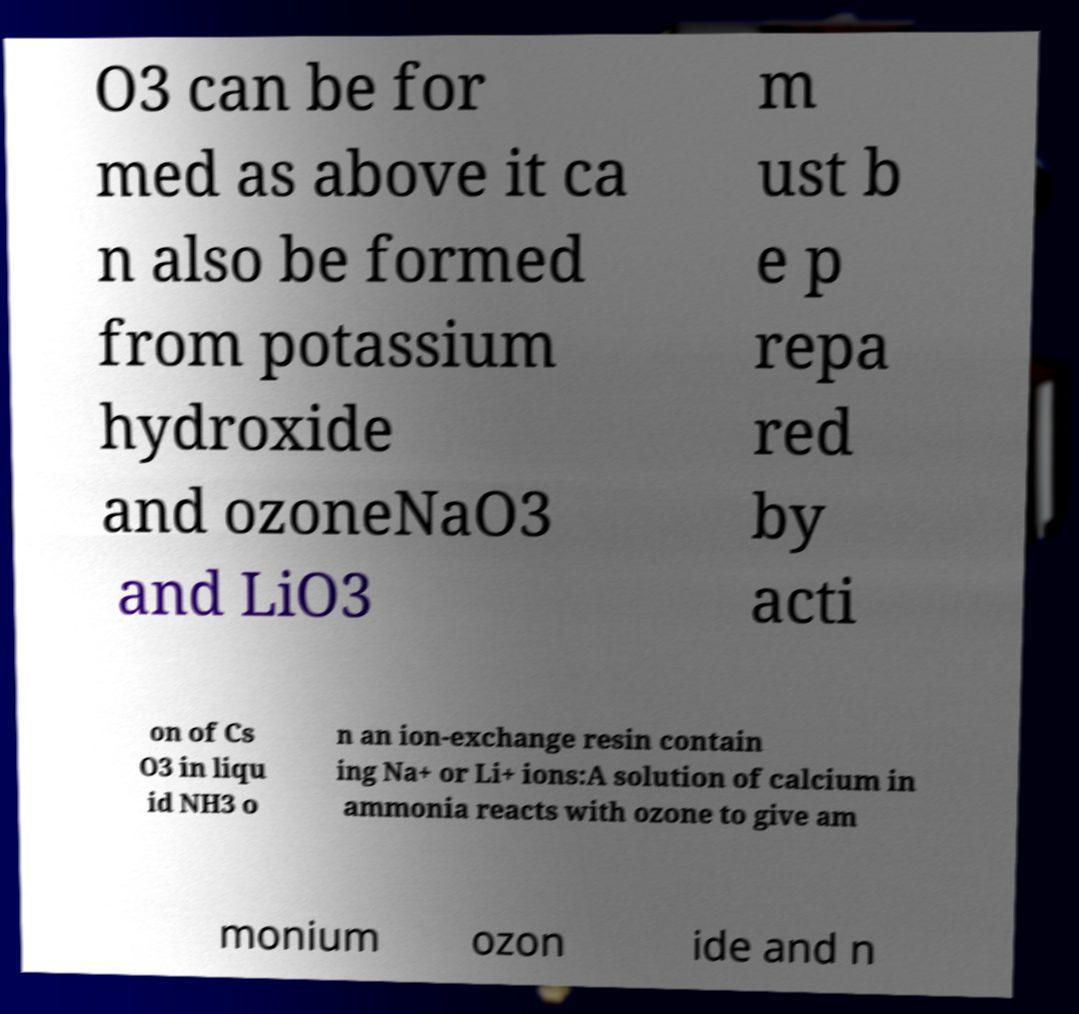Please identify and transcribe the text found in this image. O3 can be for med as above it ca n also be formed from potassium hydroxide and ozoneNaO3 and LiO3 m ust b e p repa red by acti on of Cs O3 in liqu id NH3 o n an ion-exchange resin contain ing Na+ or Li+ ions:A solution of calcium in ammonia reacts with ozone to give am monium ozon ide and n 